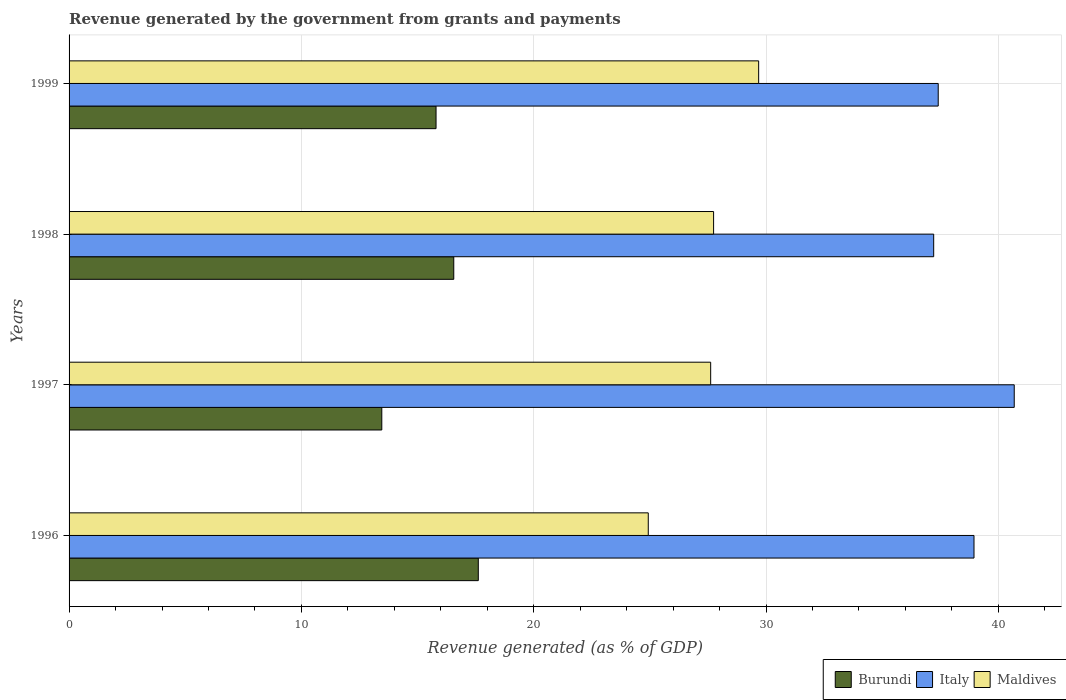How many different coloured bars are there?
Provide a short and direct response. 3. How many groups of bars are there?
Keep it short and to the point. 4. In how many cases, is the number of bars for a given year not equal to the number of legend labels?
Give a very brief answer. 0. What is the revenue generated by the government in Maldives in 1996?
Ensure brevity in your answer.  24.93. Across all years, what is the maximum revenue generated by the government in Italy?
Your answer should be compact. 40.68. Across all years, what is the minimum revenue generated by the government in Italy?
Make the answer very short. 37.22. What is the total revenue generated by the government in Italy in the graph?
Keep it short and to the point. 154.27. What is the difference between the revenue generated by the government in Maldives in 1997 and that in 1998?
Keep it short and to the point. -0.13. What is the difference between the revenue generated by the government in Maldives in 1996 and the revenue generated by the government in Italy in 1997?
Ensure brevity in your answer.  -15.75. What is the average revenue generated by the government in Burundi per year?
Provide a succinct answer. 15.86. In the year 1997, what is the difference between the revenue generated by the government in Maldives and revenue generated by the government in Italy?
Your answer should be very brief. -13.07. In how many years, is the revenue generated by the government in Maldives greater than 26 %?
Provide a succinct answer. 3. What is the ratio of the revenue generated by the government in Italy in 1996 to that in 1997?
Ensure brevity in your answer.  0.96. Is the difference between the revenue generated by the government in Maldives in 1998 and 1999 greater than the difference between the revenue generated by the government in Italy in 1998 and 1999?
Ensure brevity in your answer.  No. What is the difference between the highest and the second highest revenue generated by the government in Maldives?
Offer a terse response. 1.94. What is the difference between the highest and the lowest revenue generated by the government in Burundi?
Offer a very short reply. 4.15. In how many years, is the revenue generated by the government in Italy greater than the average revenue generated by the government in Italy taken over all years?
Your response must be concise. 2. What does the 1st bar from the top in 1997 represents?
Offer a very short reply. Maldives. What does the 1st bar from the bottom in 1998 represents?
Offer a very short reply. Burundi. Is it the case that in every year, the sum of the revenue generated by the government in Burundi and revenue generated by the government in Maldives is greater than the revenue generated by the government in Italy?
Keep it short and to the point. Yes. How many bars are there?
Ensure brevity in your answer.  12. How many years are there in the graph?
Give a very brief answer. 4. Does the graph contain grids?
Provide a short and direct response. Yes. Where does the legend appear in the graph?
Make the answer very short. Bottom right. How many legend labels are there?
Your response must be concise. 3. How are the legend labels stacked?
Keep it short and to the point. Horizontal. What is the title of the graph?
Make the answer very short. Revenue generated by the government from grants and payments. Does "Marshall Islands" appear as one of the legend labels in the graph?
Your answer should be compact. No. What is the label or title of the X-axis?
Offer a very short reply. Revenue generated (as % of GDP). What is the label or title of the Y-axis?
Provide a succinct answer. Years. What is the Revenue generated (as % of GDP) in Burundi in 1996?
Ensure brevity in your answer.  17.61. What is the Revenue generated (as % of GDP) of Italy in 1996?
Offer a terse response. 38.95. What is the Revenue generated (as % of GDP) in Maldives in 1996?
Ensure brevity in your answer.  24.93. What is the Revenue generated (as % of GDP) in Burundi in 1997?
Make the answer very short. 13.46. What is the Revenue generated (as % of GDP) of Italy in 1997?
Provide a short and direct response. 40.68. What is the Revenue generated (as % of GDP) in Maldives in 1997?
Your answer should be very brief. 27.62. What is the Revenue generated (as % of GDP) in Burundi in 1998?
Provide a succinct answer. 16.56. What is the Revenue generated (as % of GDP) of Italy in 1998?
Provide a succinct answer. 37.22. What is the Revenue generated (as % of GDP) in Maldives in 1998?
Offer a very short reply. 27.74. What is the Revenue generated (as % of GDP) of Burundi in 1999?
Your answer should be very brief. 15.8. What is the Revenue generated (as % of GDP) of Italy in 1999?
Keep it short and to the point. 37.41. What is the Revenue generated (as % of GDP) of Maldives in 1999?
Your answer should be very brief. 29.68. Across all years, what is the maximum Revenue generated (as % of GDP) in Burundi?
Offer a very short reply. 17.61. Across all years, what is the maximum Revenue generated (as % of GDP) in Italy?
Make the answer very short. 40.68. Across all years, what is the maximum Revenue generated (as % of GDP) of Maldives?
Give a very brief answer. 29.68. Across all years, what is the minimum Revenue generated (as % of GDP) in Burundi?
Keep it short and to the point. 13.46. Across all years, what is the minimum Revenue generated (as % of GDP) in Italy?
Your response must be concise. 37.22. Across all years, what is the minimum Revenue generated (as % of GDP) of Maldives?
Your answer should be compact. 24.93. What is the total Revenue generated (as % of GDP) in Burundi in the graph?
Your answer should be compact. 63.43. What is the total Revenue generated (as % of GDP) of Italy in the graph?
Make the answer very short. 154.27. What is the total Revenue generated (as % of GDP) of Maldives in the graph?
Provide a succinct answer. 109.97. What is the difference between the Revenue generated (as % of GDP) of Burundi in 1996 and that in 1997?
Your answer should be very brief. 4.15. What is the difference between the Revenue generated (as % of GDP) in Italy in 1996 and that in 1997?
Make the answer very short. -1.73. What is the difference between the Revenue generated (as % of GDP) of Maldives in 1996 and that in 1997?
Offer a terse response. -2.69. What is the difference between the Revenue generated (as % of GDP) of Burundi in 1996 and that in 1998?
Ensure brevity in your answer.  1.06. What is the difference between the Revenue generated (as % of GDP) of Italy in 1996 and that in 1998?
Give a very brief answer. 1.73. What is the difference between the Revenue generated (as % of GDP) of Maldives in 1996 and that in 1998?
Your answer should be very brief. -2.81. What is the difference between the Revenue generated (as % of GDP) of Burundi in 1996 and that in 1999?
Your response must be concise. 1.82. What is the difference between the Revenue generated (as % of GDP) in Italy in 1996 and that in 1999?
Offer a terse response. 1.54. What is the difference between the Revenue generated (as % of GDP) of Maldives in 1996 and that in 1999?
Your answer should be very brief. -4.75. What is the difference between the Revenue generated (as % of GDP) of Burundi in 1997 and that in 1998?
Give a very brief answer. -3.1. What is the difference between the Revenue generated (as % of GDP) of Italy in 1997 and that in 1998?
Keep it short and to the point. 3.47. What is the difference between the Revenue generated (as % of GDP) of Maldives in 1997 and that in 1998?
Make the answer very short. -0.13. What is the difference between the Revenue generated (as % of GDP) in Burundi in 1997 and that in 1999?
Make the answer very short. -2.34. What is the difference between the Revenue generated (as % of GDP) in Italy in 1997 and that in 1999?
Offer a very short reply. 3.27. What is the difference between the Revenue generated (as % of GDP) of Maldives in 1997 and that in 1999?
Provide a short and direct response. -2.07. What is the difference between the Revenue generated (as % of GDP) in Burundi in 1998 and that in 1999?
Give a very brief answer. 0.76. What is the difference between the Revenue generated (as % of GDP) in Italy in 1998 and that in 1999?
Keep it short and to the point. -0.19. What is the difference between the Revenue generated (as % of GDP) of Maldives in 1998 and that in 1999?
Offer a terse response. -1.94. What is the difference between the Revenue generated (as % of GDP) in Burundi in 1996 and the Revenue generated (as % of GDP) in Italy in 1997?
Your answer should be compact. -23.07. What is the difference between the Revenue generated (as % of GDP) of Burundi in 1996 and the Revenue generated (as % of GDP) of Maldives in 1997?
Offer a terse response. -10. What is the difference between the Revenue generated (as % of GDP) of Italy in 1996 and the Revenue generated (as % of GDP) of Maldives in 1997?
Your answer should be very brief. 11.34. What is the difference between the Revenue generated (as % of GDP) of Burundi in 1996 and the Revenue generated (as % of GDP) of Italy in 1998?
Your answer should be compact. -19.6. What is the difference between the Revenue generated (as % of GDP) in Burundi in 1996 and the Revenue generated (as % of GDP) in Maldives in 1998?
Provide a short and direct response. -10.13. What is the difference between the Revenue generated (as % of GDP) in Italy in 1996 and the Revenue generated (as % of GDP) in Maldives in 1998?
Your response must be concise. 11.21. What is the difference between the Revenue generated (as % of GDP) in Burundi in 1996 and the Revenue generated (as % of GDP) in Italy in 1999?
Offer a very short reply. -19.8. What is the difference between the Revenue generated (as % of GDP) in Burundi in 1996 and the Revenue generated (as % of GDP) in Maldives in 1999?
Make the answer very short. -12.07. What is the difference between the Revenue generated (as % of GDP) in Italy in 1996 and the Revenue generated (as % of GDP) in Maldives in 1999?
Your response must be concise. 9.27. What is the difference between the Revenue generated (as % of GDP) in Burundi in 1997 and the Revenue generated (as % of GDP) in Italy in 1998?
Provide a succinct answer. -23.76. What is the difference between the Revenue generated (as % of GDP) of Burundi in 1997 and the Revenue generated (as % of GDP) of Maldives in 1998?
Make the answer very short. -14.28. What is the difference between the Revenue generated (as % of GDP) of Italy in 1997 and the Revenue generated (as % of GDP) of Maldives in 1998?
Your answer should be very brief. 12.94. What is the difference between the Revenue generated (as % of GDP) of Burundi in 1997 and the Revenue generated (as % of GDP) of Italy in 1999?
Your answer should be compact. -23.95. What is the difference between the Revenue generated (as % of GDP) of Burundi in 1997 and the Revenue generated (as % of GDP) of Maldives in 1999?
Provide a short and direct response. -16.22. What is the difference between the Revenue generated (as % of GDP) of Italy in 1997 and the Revenue generated (as % of GDP) of Maldives in 1999?
Provide a succinct answer. 11. What is the difference between the Revenue generated (as % of GDP) of Burundi in 1998 and the Revenue generated (as % of GDP) of Italy in 1999?
Your response must be concise. -20.85. What is the difference between the Revenue generated (as % of GDP) in Burundi in 1998 and the Revenue generated (as % of GDP) in Maldives in 1999?
Offer a very short reply. -13.12. What is the difference between the Revenue generated (as % of GDP) of Italy in 1998 and the Revenue generated (as % of GDP) of Maldives in 1999?
Your answer should be very brief. 7.53. What is the average Revenue generated (as % of GDP) in Burundi per year?
Make the answer very short. 15.86. What is the average Revenue generated (as % of GDP) of Italy per year?
Ensure brevity in your answer.  38.57. What is the average Revenue generated (as % of GDP) in Maldives per year?
Make the answer very short. 27.49. In the year 1996, what is the difference between the Revenue generated (as % of GDP) in Burundi and Revenue generated (as % of GDP) in Italy?
Keep it short and to the point. -21.34. In the year 1996, what is the difference between the Revenue generated (as % of GDP) in Burundi and Revenue generated (as % of GDP) in Maldives?
Give a very brief answer. -7.32. In the year 1996, what is the difference between the Revenue generated (as % of GDP) of Italy and Revenue generated (as % of GDP) of Maldives?
Your response must be concise. 14.02. In the year 1997, what is the difference between the Revenue generated (as % of GDP) of Burundi and Revenue generated (as % of GDP) of Italy?
Make the answer very short. -27.22. In the year 1997, what is the difference between the Revenue generated (as % of GDP) of Burundi and Revenue generated (as % of GDP) of Maldives?
Provide a short and direct response. -14.16. In the year 1997, what is the difference between the Revenue generated (as % of GDP) of Italy and Revenue generated (as % of GDP) of Maldives?
Your answer should be very brief. 13.07. In the year 1998, what is the difference between the Revenue generated (as % of GDP) of Burundi and Revenue generated (as % of GDP) of Italy?
Keep it short and to the point. -20.66. In the year 1998, what is the difference between the Revenue generated (as % of GDP) in Burundi and Revenue generated (as % of GDP) in Maldives?
Your answer should be compact. -11.18. In the year 1998, what is the difference between the Revenue generated (as % of GDP) of Italy and Revenue generated (as % of GDP) of Maldives?
Make the answer very short. 9.47. In the year 1999, what is the difference between the Revenue generated (as % of GDP) of Burundi and Revenue generated (as % of GDP) of Italy?
Give a very brief answer. -21.62. In the year 1999, what is the difference between the Revenue generated (as % of GDP) of Burundi and Revenue generated (as % of GDP) of Maldives?
Your answer should be compact. -13.89. In the year 1999, what is the difference between the Revenue generated (as % of GDP) of Italy and Revenue generated (as % of GDP) of Maldives?
Provide a short and direct response. 7.73. What is the ratio of the Revenue generated (as % of GDP) in Burundi in 1996 to that in 1997?
Keep it short and to the point. 1.31. What is the ratio of the Revenue generated (as % of GDP) in Italy in 1996 to that in 1997?
Keep it short and to the point. 0.96. What is the ratio of the Revenue generated (as % of GDP) in Maldives in 1996 to that in 1997?
Give a very brief answer. 0.9. What is the ratio of the Revenue generated (as % of GDP) of Burundi in 1996 to that in 1998?
Offer a terse response. 1.06. What is the ratio of the Revenue generated (as % of GDP) in Italy in 1996 to that in 1998?
Keep it short and to the point. 1.05. What is the ratio of the Revenue generated (as % of GDP) in Maldives in 1996 to that in 1998?
Provide a succinct answer. 0.9. What is the ratio of the Revenue generated (as % of GDP) of Burundi in 1996 to that in 1999?
Give a very brief answer. 1.12. What is the ratio of the Revenue generated (as % of GDP) of Italy in 1996 to that in 1999?
Provide a short and direct response. 1.04. What is the ratio of the Revenue generated (as % of GDP) of Maldives in 1996 to that in 1999?
Make the answer very short. 0.84. What is the ratio of the Revenue generated (as % of GDP) of Burundi in 1997 to that in 1998?
Make the answer very short. 0.81. What is the ratio of the Revenue generated (as % of GDP) of Italy in 1997 to that in 1998?
Provide a succinct answer. 1.09. What is the ratio of the Revenue generated (as % of GDP) in Burundi in 1997 to that in 1999?
Offer a very short reply. 0.85. What is the ratio of the Revenue generated (as % of GDP) of Italy in 1997 to that in 1999?
Your answer should be compact. 1.09. What is the ratio of the Revenue generated (as % of GDP) of Maldives in 1997 to that in 1999?
Make the answer very short. 0.93. What is the ratio of the Revenue generated (as % of GDP) in Burundi in 1998 to that in 1999?
Provide a succinct answer. 1.05. What is the ratio of the Revenue generated (as % of GDP) of Italy in 1998 to that in 1999?
Make the answer very short. 0.99. What is the ratio of the Revenue generated (as % of GDP) in Maldives in 1998 to that in 1999?
Your response must be concise. 0.93. What is the difference between the highest and the second highest Revenue generated (as % of GDP) of Burundi?
Provide a succinct answer. 1.06. What is the difference between the highest and the second highest Revenue generated (as % of GDP) of Italy?
Offer a very short reply. 1.73. What is the difference between the highest and the second highest Revenue generated (as % of GDP) in Maldives?
Offer a terse response. 1.94. What is the difference between the highest and the lowest Revenue generated (as % of GDP) in Burundi?
Offer a terse response. 4.15. What is the difference between the highest and the lowest Revenue generated (as % of GDP) in Italy?
Provide a short and direct response. 3.47. What is the difference between the highest and the lowest Revenue generated (as % of GDP) in Maldives?
Give a very brief answer. 4.75. 